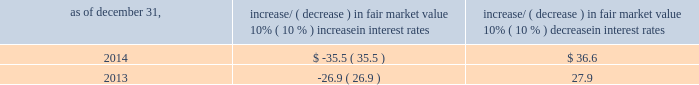Item 7a .
Quantitative and qualitative disclosures about market risk ( amounts in millions ) in the normal course of business , we are exposed to market risks related to interest rates , foreign currency rates and certain balance sheet items .
From time to time , we use derivative instruments , pursuant to established guidelines and policies , to manage some portion of these risks .
Derivative instruments utilized in our hedging activities are viewed as risk management tools and are not used for trading or speculative purposes .
Interest rates our exposure to market risk for changes in interest rates relates primarily to the fair market value and cash flows of our debt obligations .
The majority of our debt ( approximately 91% ( 91 % ) and 86% ( 86 % ) as of december 31 , 2014 and 2013 , respectively ) bears interest at fixed rates .
We do have debt with variable interest rates , but a 10% ( 10 % ) increase or decrease in interest rates would not be material to our interest expense or cash flows .
The fair market value of our debt is sensitive to changes in interest rates , and the impact of a 10% ( 10 % ) change in interest rates is summarized below .
Increase/ ( decrease ) in fair market value as of december 31 , 10% ( 10 % ) increase in interest rates 10% ( 10 % ) decrease in interest rates .
We have used interest rate swaps for risk management purposes to manage our exposure to changes in interest rates .
We do not have any interest rate swaps outstanding as of december 31 , 2014 .
We had $ 1667.2 of cash , cash equivalents and marketable securities as of december 31 , 2014 that we generally invest in conservative , short-term bank deposits or securities .
The interest income generated from these investments is subject to both domestic and foreign interest rate movements .
During 2014 and 2013 , we had interest income of $ 27.4 and $ 24.7 , respectively .
Based on our 2014 results , a 100-basis-point increase or decrease in interest rates would affect our interest income by approximately $ 16.7 , assuming that all cash , cash equivalents and marketable securities are impacted in the same manner and balances remain constant from year-end 2014 levels .
Foreign currency rates we are subject to translation and transaction risks related to changes in foreign currency exchange rates .
Since we report revenues and expenses in u.s .
Dollars , changes in exchange rates may either positively or negatively affect our consolidated revenues and expenses ( as expressed in u.s .
Dollars ) from foreign operations .
The primary foreign currencies that impacted our results during 2014 included the argentine peso , australian dollar , brazilian real and british pound sterling .
Based on 2014 exchange rates and operating results , if the u.s .
Dollar were to strengthen or weaken by 10% ( 10 % ) , we currently estimate operating income would decrease or increase approximately 4% ( 4 % ) , assuming that all currencies are impacted in the same manner and our international revenue and expenses remain constant at 2014 levels .
The functional currency of our foreign operations is generally their respective local currency .
Assets and liabilities are translated at the exchange rates in effect at the balance sheet date , and revenues and expenses are translated at the average exchange rates during the period presented .
The resulting translation adjustments are recorded as a component of accumulated other comprehensive loss , net of tax , in the stockholders 2019 equity section of our consolidated balance sheets .
Our foreign subsidiaries generally collect revenues and pay expenses in their functional currency , mitigating transaction risk .
However , certain subsidiaries may enter into transactions in currencies other than their functional currency .
Assets and liabilities denominated in currencies other than the functional currency are susceptible to movements in foreign currency until final settlement .
Currency transaction gains or losses primarily arising from transactions in currencies other than the functional currency are included in office and general expenses .
We have not entered into a material amount of foreign currency forward exchange contracts or other derivative financial instruments to hedge the effects of potential adverse fluctuations in foreign currency exchange rates. .
Assuming that all cash , cash equivalents and marketable securities are invested to generate the stated interest income in 2014 , what would be the average interest rate? 
Computations: (27.4 / 1667.2)
Answer: 0.01643. 